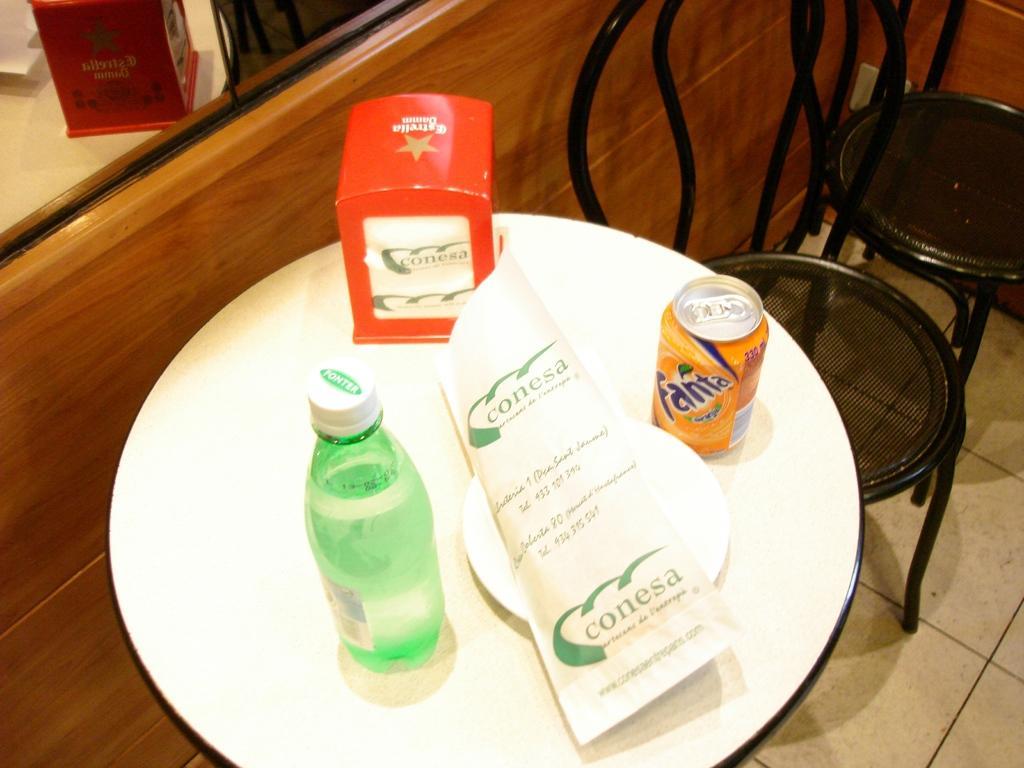Can you describe this image briefly? In this image In the middle there is a table on that there is a plate, tin, box and bottle. On the right there are two chairs. In the background there is a mirror. 